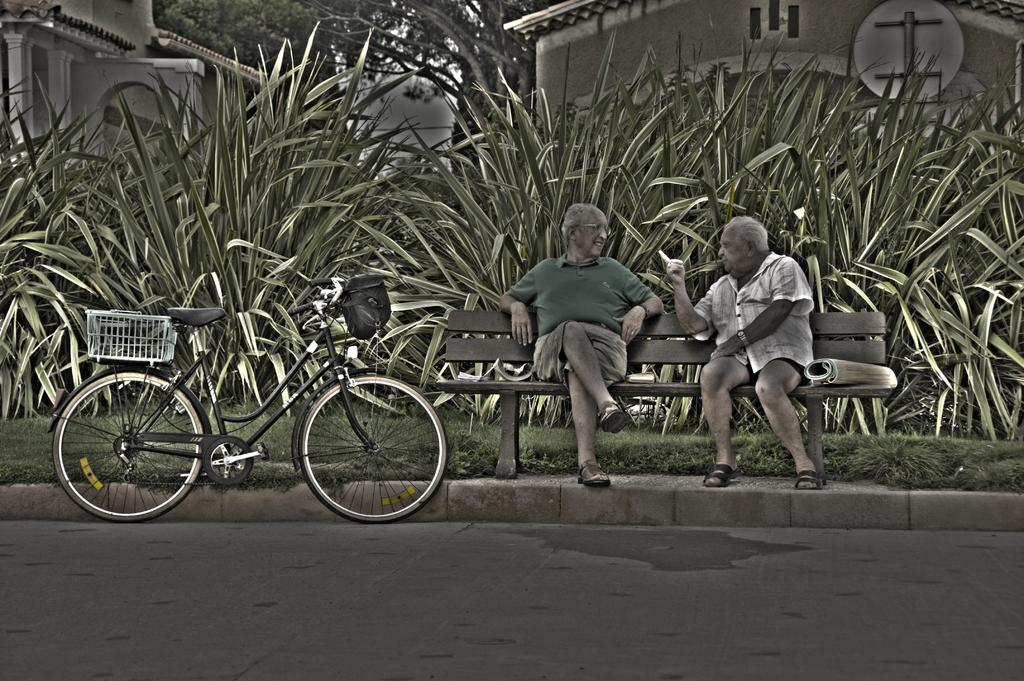What is on the road in the image? There is a bicycle on the road in the image. What are the two persons doing in the image? Two persons are seated on a bench in the image. What can be seen in the background of the image? Plants, trees, and buildings are visible in the background of the image. What type of coat is hanging on the gate in the image? There is no coat or gate present in the image. Is there any snow visible in the image? There is no snow visible in the image. 